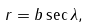Convert formula to latex. <formula><loc_0><loc_0><loc_500><loc_500>r = b \sec \lambda ,</formula> 